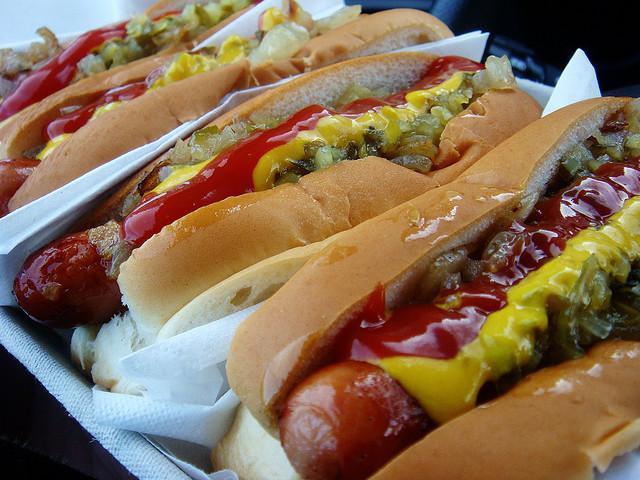How many hot dogs are visible?
Give a very brief answer. 4. How many hot dogs are there?
Give a very brief answer. 4. How many zebras are on the road?
Give a very brief answer. 0. 